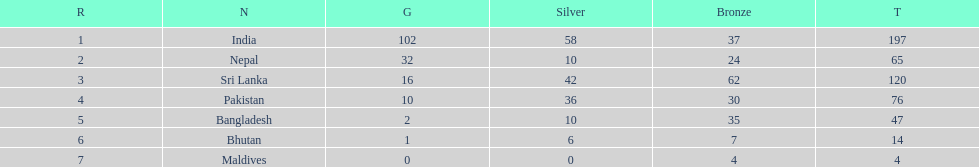What is the difference in total number of medals between india and nepal? 132. 